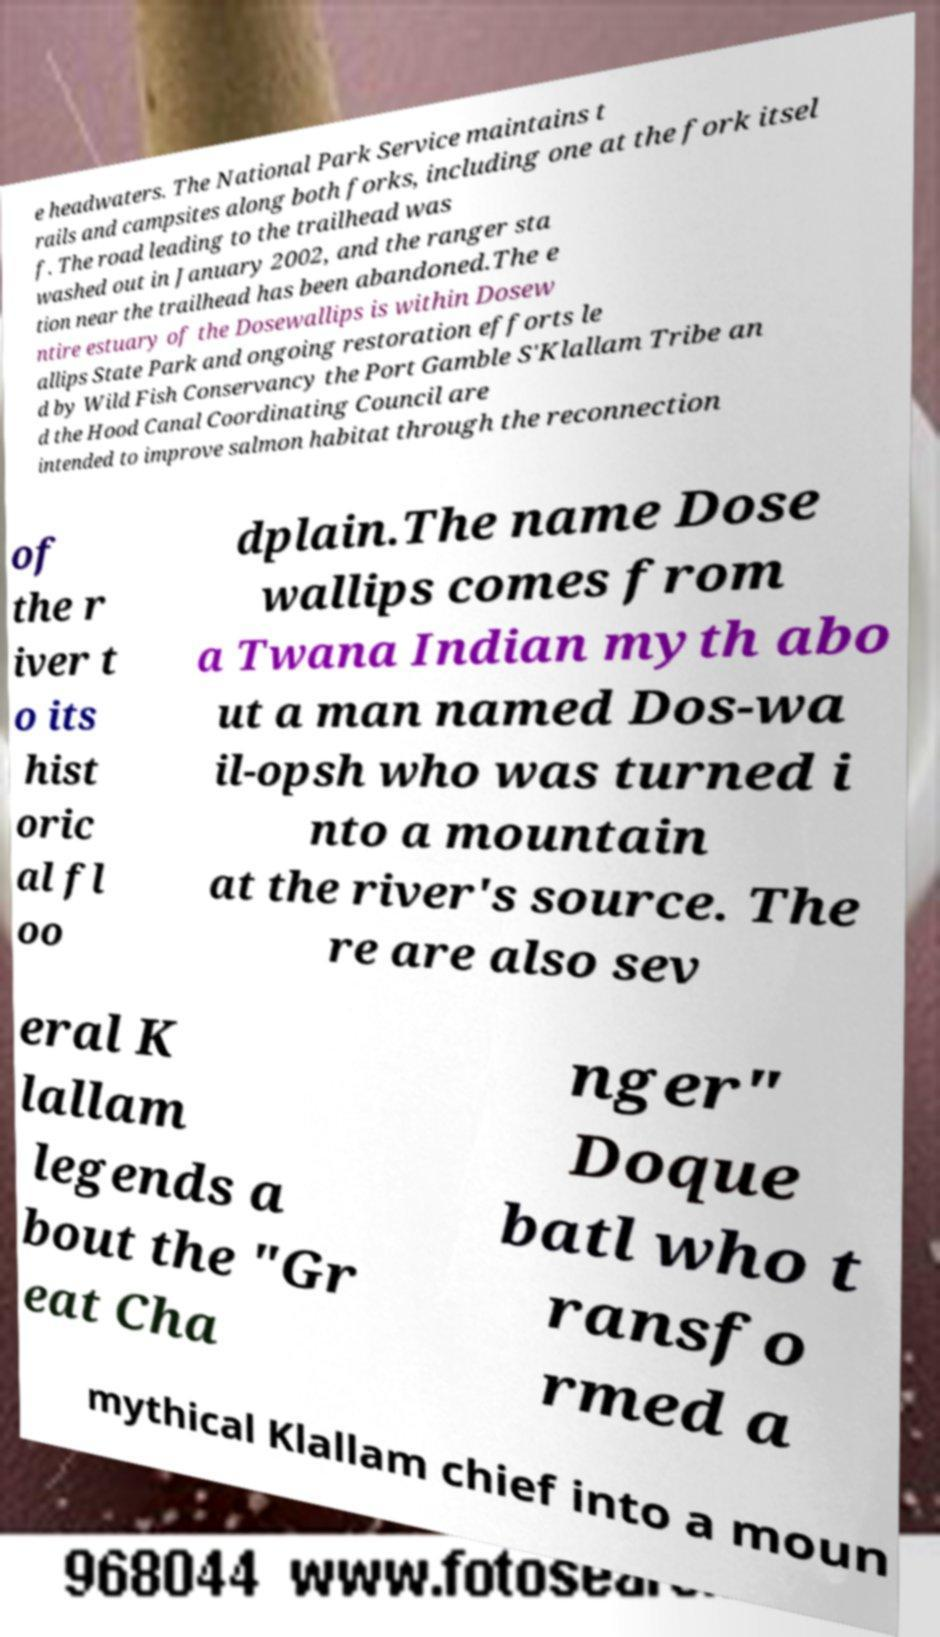What messages or text are displayed in this image? I need them in a readable, typed format. e headwaters. The National Park Service maintains t rails and campsites along both forks, including one at the fork itsel f. The road leading to the trailhead was washed out in January 2002, and the ranger sta tion near the trailhead has been abandoned.The e ntire estuary of the Dosewallips is within Dosew allips State Park and ongoing restoration efforts le d by Wild Fish Conservancy the Port Gamble S'Klallam Tribe an d the Hood Canal Coordinating Council are intended to improve salmon habitat through the reconnection of the r iver t o its hist oric al fl oo dplain.The name Dose wallips comes from a Twana Indian myth abo ut a man named Dos-wa il-opsh who was turned i nto a mountain at the river's source. The re are also sev eral K lallam legends a bout the "Gr eat Cha nger" Doque batl who t ransfo rmed a mythical Klallam chief into a moun 